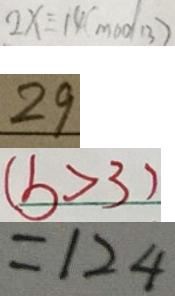<formula> <loc_0><loc_0><loc_500><loc_500>2 x \equiv 1 4 ( m o d 1 3 ) 
 2 9 
 ( b > 3 ) 
 = 1 2 4</formula> 